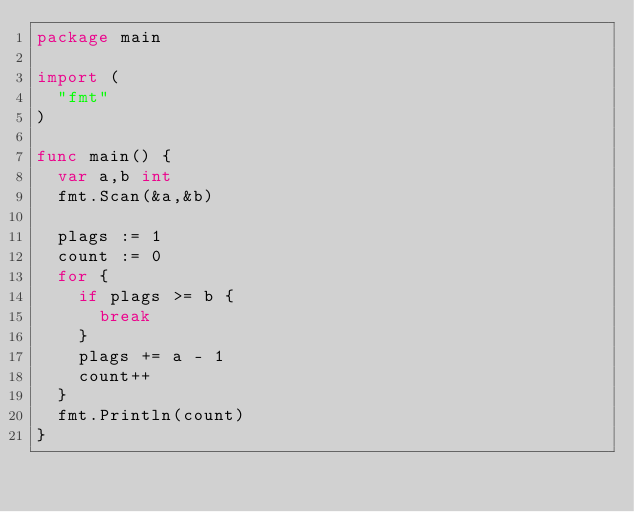Convert code to text. <code><loc_0><loc_0><loc_500><loc_500><_Go_>package main

import (
	"fmt"
)

func main() {
	var a,b int
	fmt.Scan(&a,&b)

	plags := 1
	count := 0
	for {
		if plags >= b {
			break
		}
		plags += a - 1
		count++
	}
	fmt.Println(count)
}</code> 